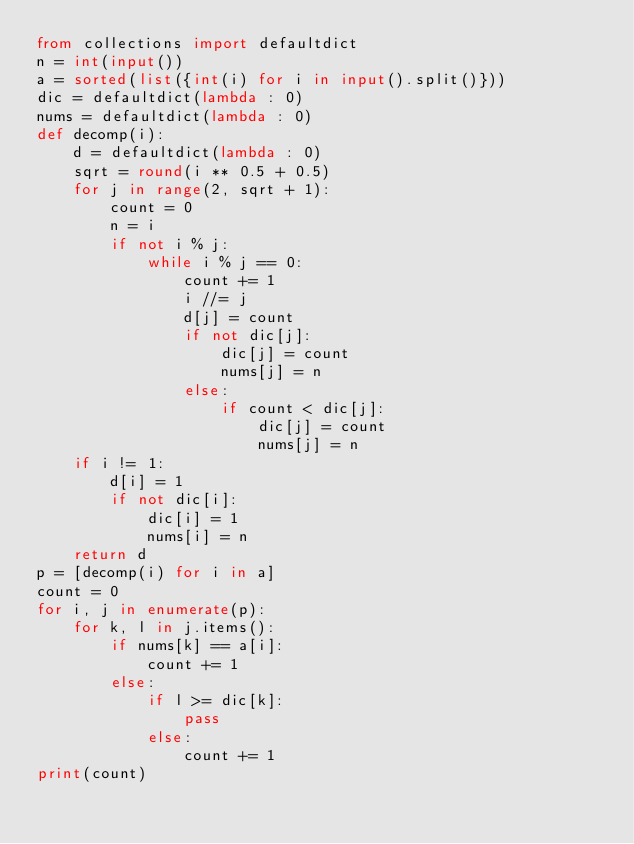<code> <loc_0><loc_0><loc_500><loc_500><_Python_>from collections import defaultdict
n = int(input())
a = sorted(list({int(i) for i in input().split()}))
dic = defaultdict(lambda : 0)
nums = defaultdict(lambda : 0)
def decomp(i):
    d = defaultdict(lambda : 0)
    sqrt = round(i ** 0.5 + 0.5)
    for j in range(2, sqrt + 1):
        count = 0
        n = i
        if not i % j:
            while i % j == 0:
                count += 1
                i //= j
                d[j] = count
                if not dic[j]:
                    dic[j] = count
                    nums[j] = n
                else:
                    if count < dic[j]:
                        dic[j] = count
                        nums[j] = n
    if i != 1:
        d[i] = 1
        if not dic[i]:
            dic[i] = 1
            nums[i] = n
    return d
p = [decomp(i) for i in a]
count = 0
for i, j in enumerate(p):
    for k, l in j.items():
        if nums[k] == a[i]:
            count += 1
        else:
            if l >= dic[k]:
                pass
            else:
                count += 1
print(count)</code> 